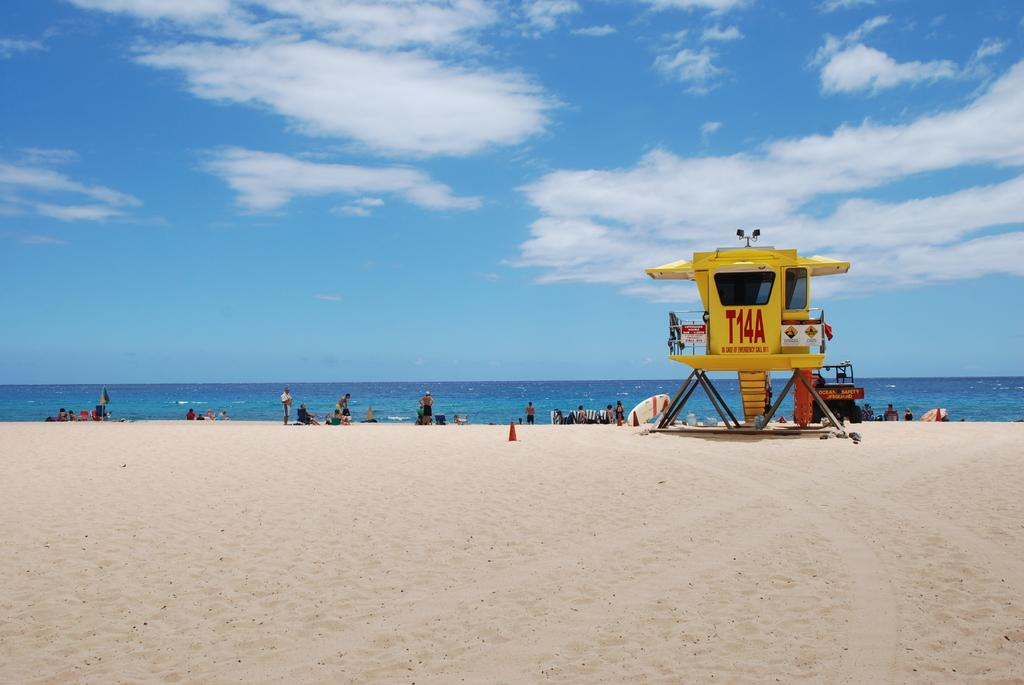<image>
Give a short and clear explanation of the subsequent image. A beach with a yellow lifeguard hut numbered T14A. 